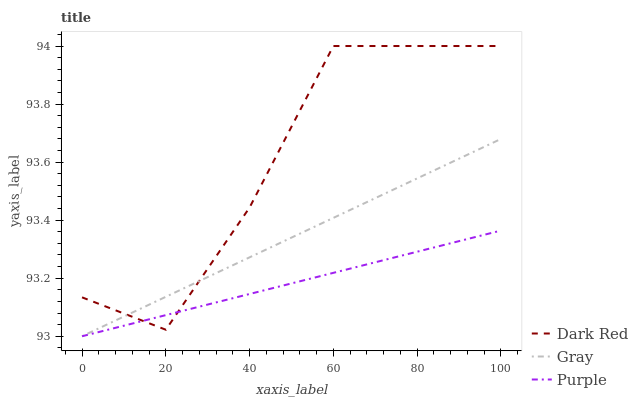Does Purple have the minimum area under the curve?
Answer yes or no. Yes. Does Dark Red have the maximum area under the curve?
Answer yes or no. Yes. Does Gray have the minimum area under the curve?
Answer yes or no. No. Does Gray have the maximum area under the curve?
Answer yes or no. No. Is Gray the smoothest?
Answer yes or no. Yes. Is Dark Red the roughest?
Answer yes or no. Yes. Is Dark Red the smoothest?
Answer yes or no. No. Is Gray the roughest?
Answer yes or no. No. Does Dark Red have the lowest value?
Answer yes or no. No. Does Dark Red have the highest value?
Answer yes or no. Yes. Does Gray have the highest value?
Answer yes or no. No. Does Purple intersect Dark Red?
Answer yes or no. Yes. Is Purple less than Dark Red?
Answer yes or no. No. Is Purple greater than Dark Red?
Answer yes or no. No. 